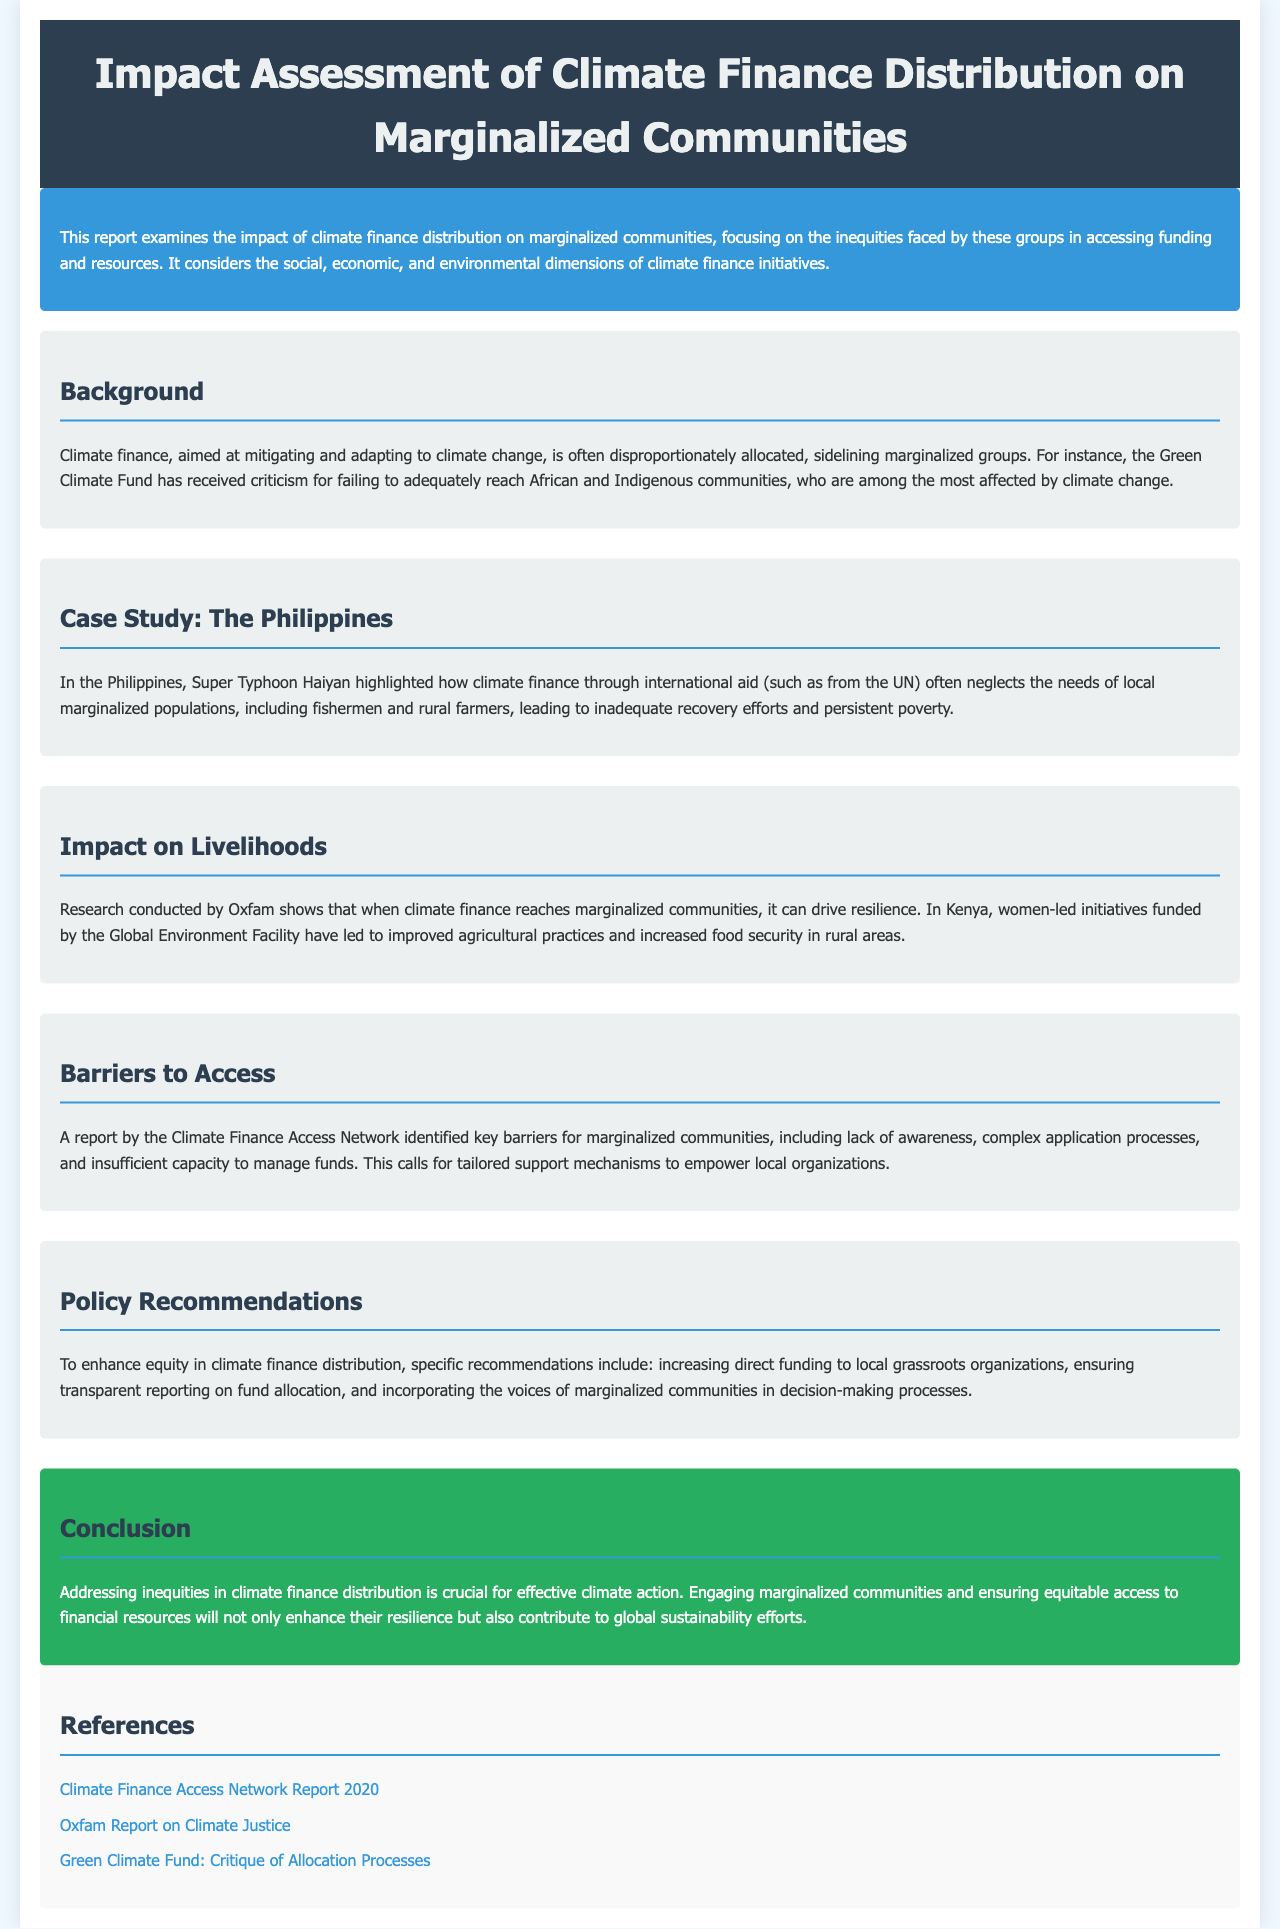What is the main focus of the report? The report examines the impact of climate finance distribution on marginalized communities, focusing on inequities in accessing funding.
Answer: climate finance distribution Which organization received criticism for its allocation practices? The report mentions that the Green Climate Fund has received criticism for failing to adequately reach certain communities.
Answer: Green Climate Fund What natural disaster is highlighted in the case study? The case study discusses the impact of Super Typhoon Haiyan on marginalized populations in the Philippines.
Answer: Super Typhoon Haiyan What is a key barrier faced by marginalized communities in accessing climate finance? The report identifies the lack of awareness as one of the key barriers preventing access to climate finance.
Answer: lack of awareness What impact has climate finance had in Kenya according to the report? The report states that climate finance reaching marginalized communities in Kenya has supported women-led initiatives that improved agricultural practices.
Answer: improved agricultural practices How many recommendations are provided in the policy recommendations section? The document outlines several specific recommendations for enhancing equity in climate finance distribution.
Answer: specific recommendations What is the conclusion regarding inequities in climate finance distribution? The report concludes that addressing inequities in climate finance distribution is crucial for effective climate action.
Answer: effective climate action Who authored a report on climate justice mentioned in the references? The report references Oxfam for their research on climate justice.
Answer: Oxfam What is a suggestion for enhancing climate finance equity? One of the suggestions is to increase direct funding to local grassroots organizations.
Answer: increase direct funding to local grassroots organizations 